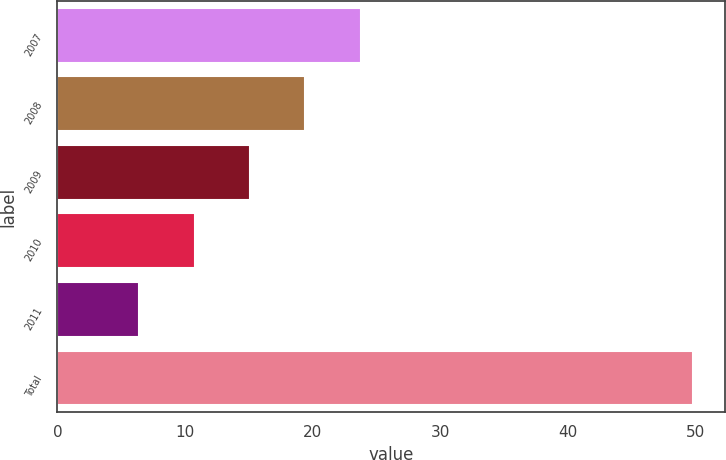Convert chart. <chart><loc_0><loc_0><loc_500><loc_500><bar_chart><fcel>2007<fcel>2008<fcel>2009<fcel>2010<fcel>2011<fcel>Total<nl><fcel>23.76<fcel>19.42<fcel>15.08<fcel>10.74<fcel>6.4<fcel>49.8<nl></chart> 